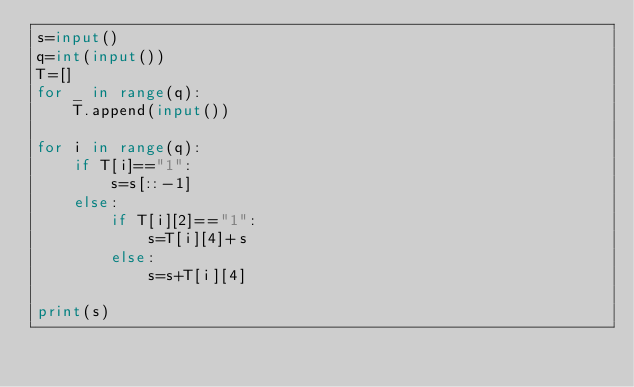Convert code to text. <code><loc_0><loc_0><loc_500><loc_500><_Python_>s=input()
q=int(input())
T=[]
for _ in range(q):
    T.append(input())
    
for i in range(q):
    if T[i]=="1":
        s=s[::-1]
    else:
        if T[i][2]=="1":
            s=T[i][4]+s
        else:
            s=s+T[i][4]
        
print(s)</code> 